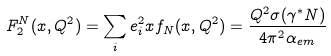Convert formula to latex. <formula><loc_0><loc_0><loc_500><loc_500>F _ { 2 } ^ { N } ( x , Q ^ { 2 } ) = \sum _ { i } e _ { i } ^ { 2 } x f _ { N } ( x , Q ^ { 2 } ) = \frac { Q ^ { 2 } \sigma ( \gamma ^ { * } N ) } { 4 \pi ^ { 2 } \alpha _ { e m } }</formula> 